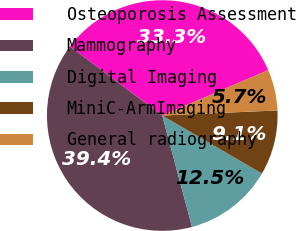<chart> <loc_0><loc_0><loc_500><loc_500><pie_chart><fcel>Osteoporosis Assessment<fcel>Mammography<fcel>Digital Imaging<fcel>MiniC-ArmImaging<fcel>General radiography<nl><fcel>33.34%<fcel>39.37%<fcel>12.46%<fcel>9.09%<fcel>5.73%<nl></chart> 